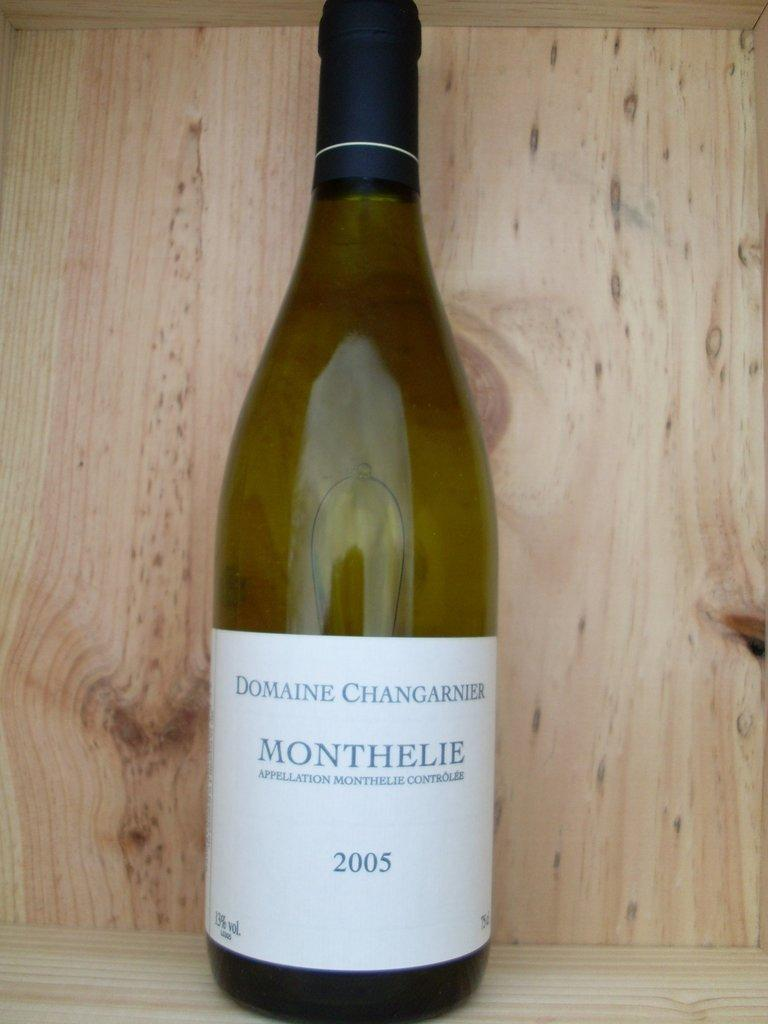<image>
Share a concise interpretation of the image provided. a close up of a bottle of Monthelie 2005 wine 